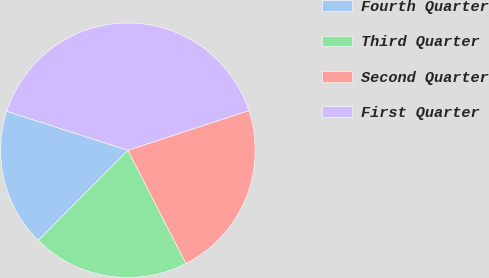<chart> <loc_0><loc_0><loc_500><loc_500><pie_chart><fcel>Fourth Quarter<fcel>Third Quarter<fcel>Second Quarter<fcel>First Quarter<nl><fcel>17.5%<fcel>20.0%<fcel>22.5%<fcel>40.0%<nl></chart> 